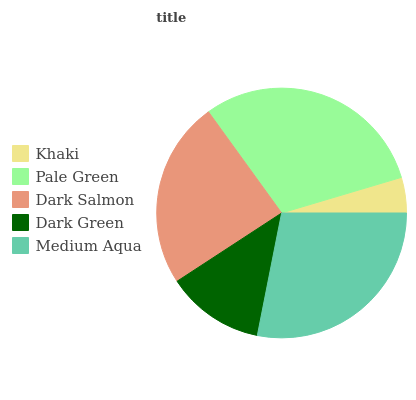Is Khaki the minimum?
Answer yes or no. Yes. Is Pale Green the maximum?
Answer yes or no. Yes. Is Dark Salmon the minimum?
Answer yes or no. No. Is Dark Salmon the maximum?
Answer yes or no. No. Is Pale Green greater than Dark Salmon?
Answer yes or no. Yes. Is Dark Salmon less than Pale Green?
Answer yes or no. Yes. Is Dark Salmon greater than Pale Green?
Answer yes or no. No. Is Pale Green less than Dark Salmon?
Answer yes or no. No. Is Dark Salmon the high median?
Answer yes or no. Yes. Is Dark Salmon the low median?
Answer yes or no. Yes. Is Medium Aqua the high median?
Answer yes or no. No. Is Medium Aqua the low median?
Answer yes or no. No. 